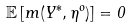Convert formula to latex. <formula><loc_0><loc_0><loc_500><loc_500>\mathbb { E } \left [ m ( Y ^ { * } , \eta ^ { o } ) \right ] = 0</formula> 